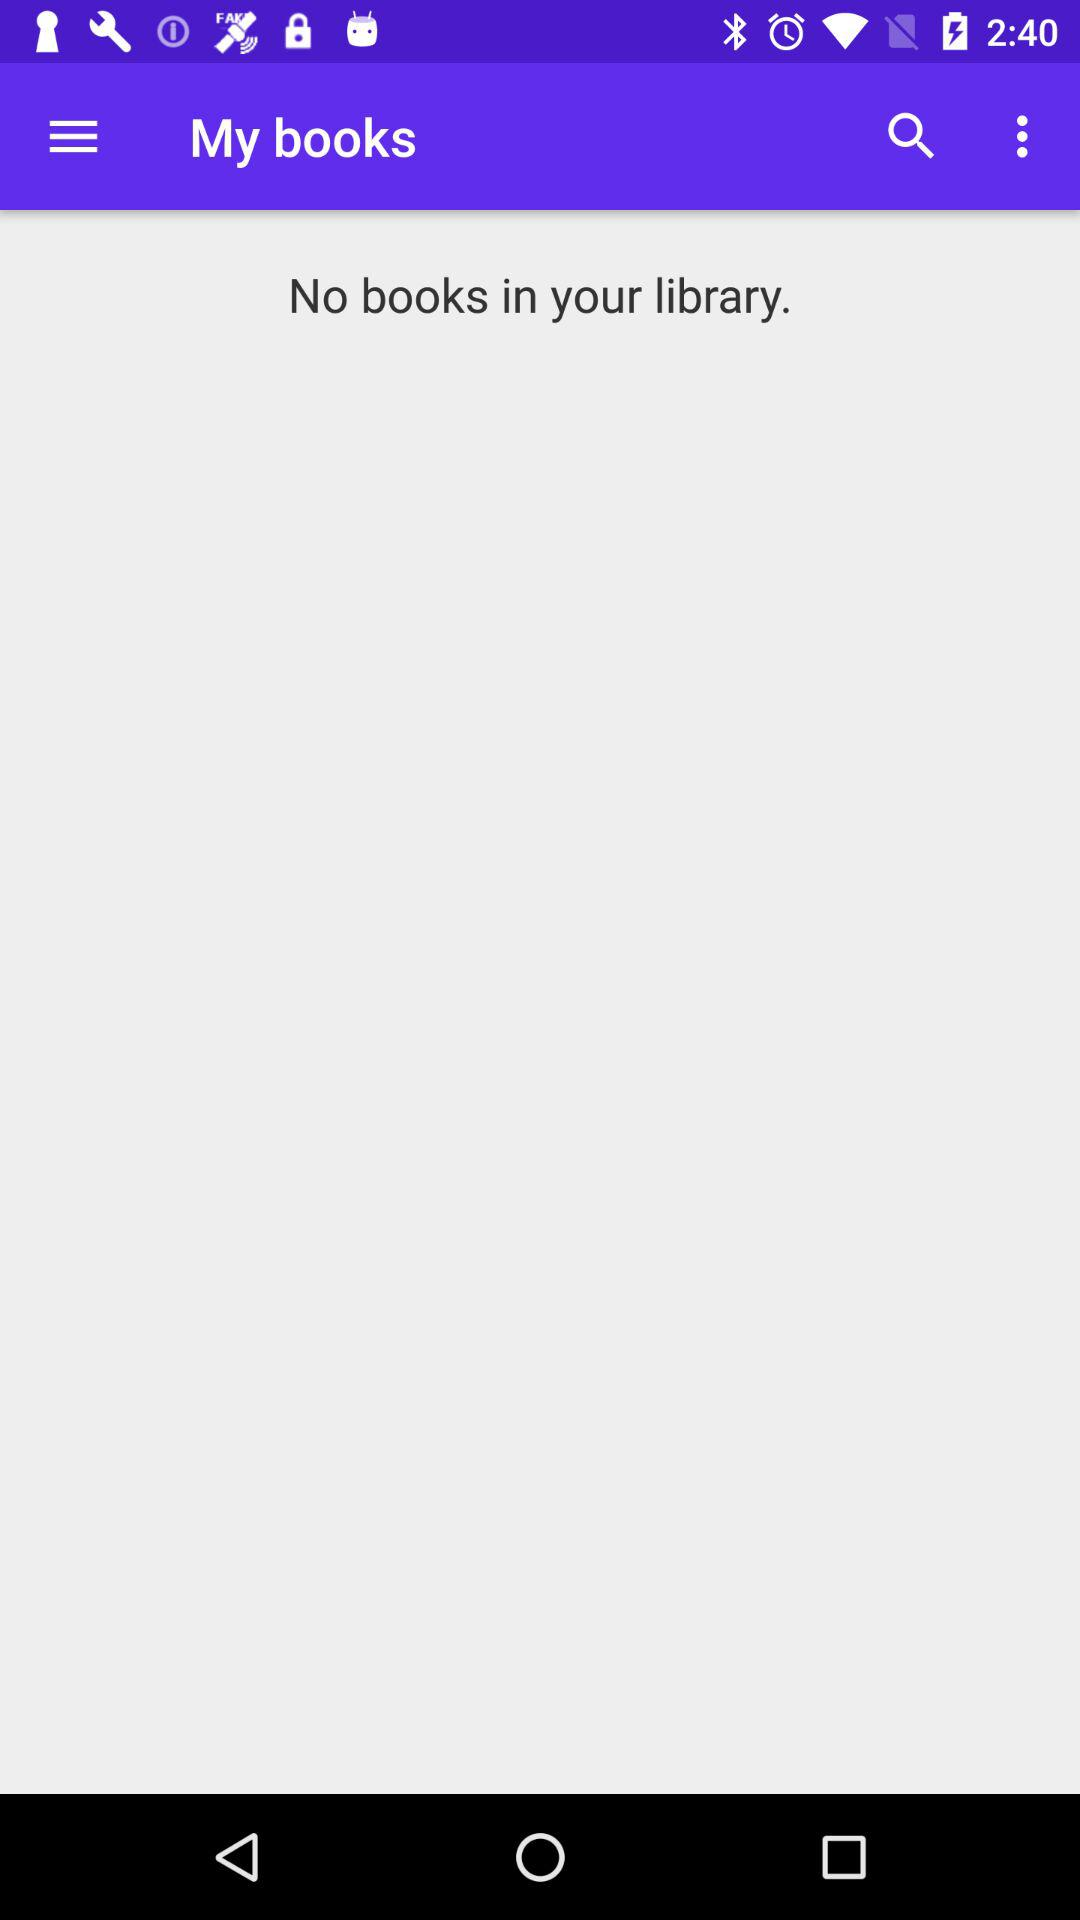Are there any books available in the library? There are no books available in the library. 